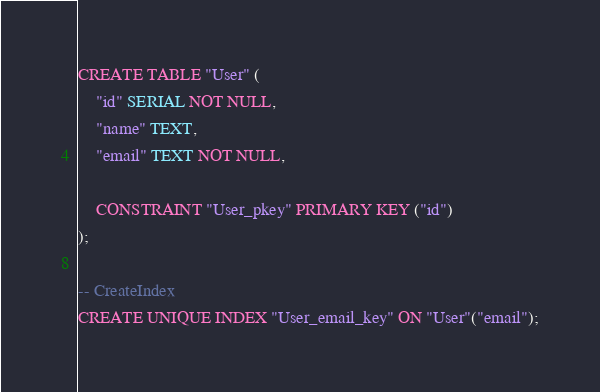Convert code to text. <code><loc_0><loc_0><loc_500><loc_500><_SQL_>CREATE TABLE "User" (
    "id" SERIAL NOT NULL,
    "name" TEXT,
    "email" TEXT NOT NULL,

    CONSTRAINT "User_pkey" PRIMARY KEY ("id")
);

-- CreateIndex
CREATE UNIQUE INDEX "User_email_key" ON "User"("email");
</code> 